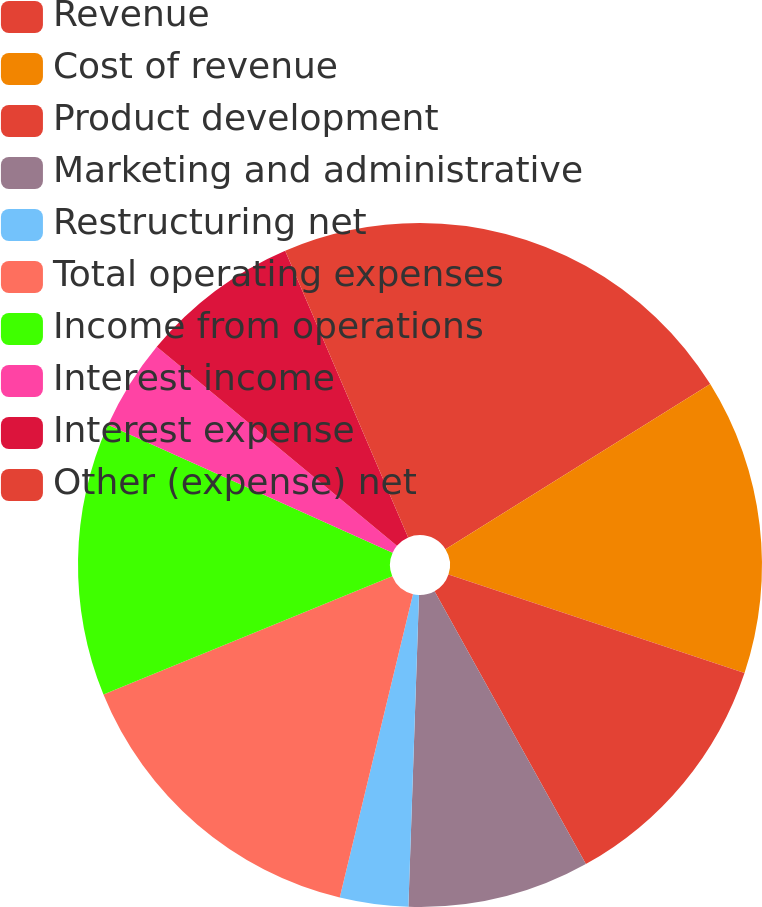Convert chart. <chart><loc_0><loc_0><loc_500><loc_500><pie_chart><fcel>Revenue<fcel>Cost of revenue<fcel>Product development<fcel>Marketing and administrative<fcel>Restructuring net<fcel>Total operating expenses<fcel>Income from operations<fcel>Interest income<fcel>Interest expense<fcel>Other (expense) net<nl><fcel>16.13%<fcel>13.98%<fcel>11.83%<fcel>8.6%<fcel>3.23%<fcel>15.05%<fcel>12.9%<fcel>4.3%<fcel>7.53%<fcel>6.45%<nl></chart> 